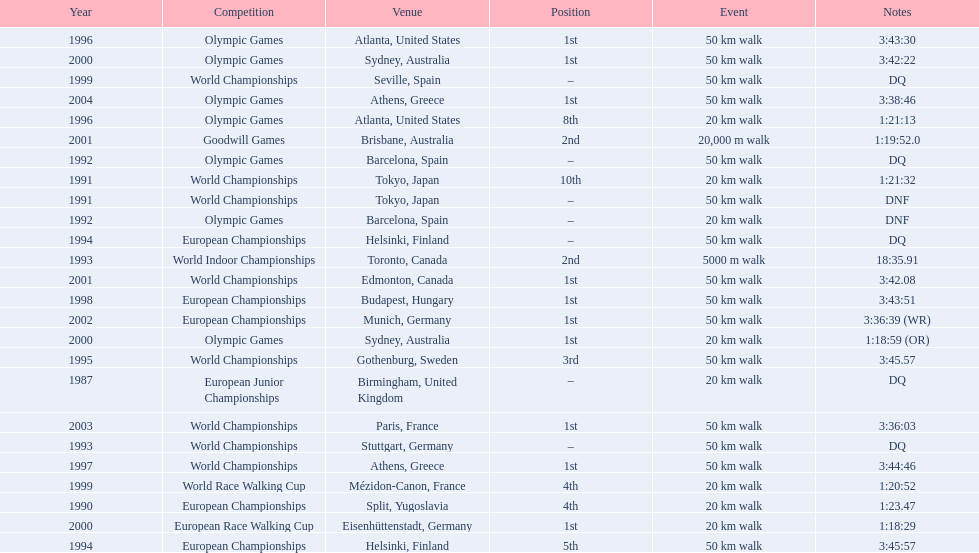Which of the competitions were 50 km walks? World Championships, Olympic Games, World Championships, European Championships, European Championships, World Championships, Olympic Games, World Championships, European Championships, World Championships, Olympic Games, World Championships, European Championships, World Championships, Olympic Games. Of these, which took place during or after the year 2000? Olympic Games, World Championships, European Championships, World Championships, Olympic Games. From these, which took place in athens, greece? Olympic Games. What was the time to finish for this competition? 3:38:46. Would you mind parsing the complete table? {'header': ['Year', 'Competition', 'Venue', 'Position', 'Event', 'Notes'], 'rows': [['1996', 'Olympic Games', 'Atlanta, United States', '1st', '50\xa0km walk', '3:43:30'], ['2000', 'Olympic Games', 'Sydney, Australia', '1st', '50\xa0km walk', '3:42:22'], ['1999', 'World Championships', 'Seville, Spain', '–', '50\xa0km walk', 'DQ'], ['2004', 'Olympic Games', 'Athens, Greece', '1st', '50\xa0km walk', '3:38:46'], ['1996', 'Olympic Games', 'Atlanta, United States', '8th', '20\xa0km walk', '1:21:13'], ['2001', 'Goodwill Games', 'Brisbane, Australia', '2nd', '20,000 m walk', '1:19:52.0'], ['1992', 'Olympic Games', 'Barcelona, Spain', '–', '50\xa0km walk', 'DQ'], ['1991', 'World Championships', 'Tokyo, Japan', '10th', '20\xa0km walk', '1:21:32'], ['1991', 'World Championships', 'Tokyo, Japan', '–', '50\xa0km walk', 'DNF'], ['1992', 'Olympic Games', 'Barcelona, Spain', '–', '20\xa0km walk', 'DNF'], ['1994', 'European Championships', 'Helsinki, Finland', '–', '50\xa0km walk', 'DQ'], ['1993', 'World Indoor Championships', 'Toronto, Canada', '2nd', '5000 m walk', '18:35.91'], ['2001', 'World Championships', 'Edmonton, Canada', '1st', '50\xa0km walk', '3:42.08'], ['1998', 'European Championships', 'Budapest, Hungary', '1st', '50\xa0km walk', '3:43:51'], ['2002', 'European Championships', 'Munich, Germany', '1st', '50\xa0km walk', '3:36:39 (WR)'], ['2000', 'Olympic Games', 'Sydney, Australia', '1st', '20\xa0km walk', '1:18:59 (OR)'], ['1995', 'World Championships', 'Gothenburg, Sweden', '3rd', '50\xa0km walk', '3:45.57'], ['1987', 'European Junior Championships', 'Birmingham, United Kingdom', '–', '20\xa0km walk', 'DQ'], ['2003', 'World Championships', 'Paris, France', '1st', '50\xa0km walk', '3:36:03'], ['1993', 'World Championships', 'Stuttgart, Germany', '–', '50\xa0km walk', 'DQ'], ['1997', 'World Championships', 'Athens, Greece', '1st', '50\xa0km walk', '3:44:46'], ['1999', 'World Race Walking Cup', 'Mézidon-Canon, France', '4th', '20\xa0km walk', '1:20:52'], ['1990', 'European Championships', 'Split, Yugoslavia', '4th', '20\xa0km walk', '1:23.47'], ['2000', 'European Race Walking Cup', 'Eisenhüttenstadt, Germany', '1st', '20\xa0km walk', '1:18:29'], ['1994', 'European Championships', 'Helsinki, Finland', '5th', '50\xa0km walk', '3:45:57']]} 